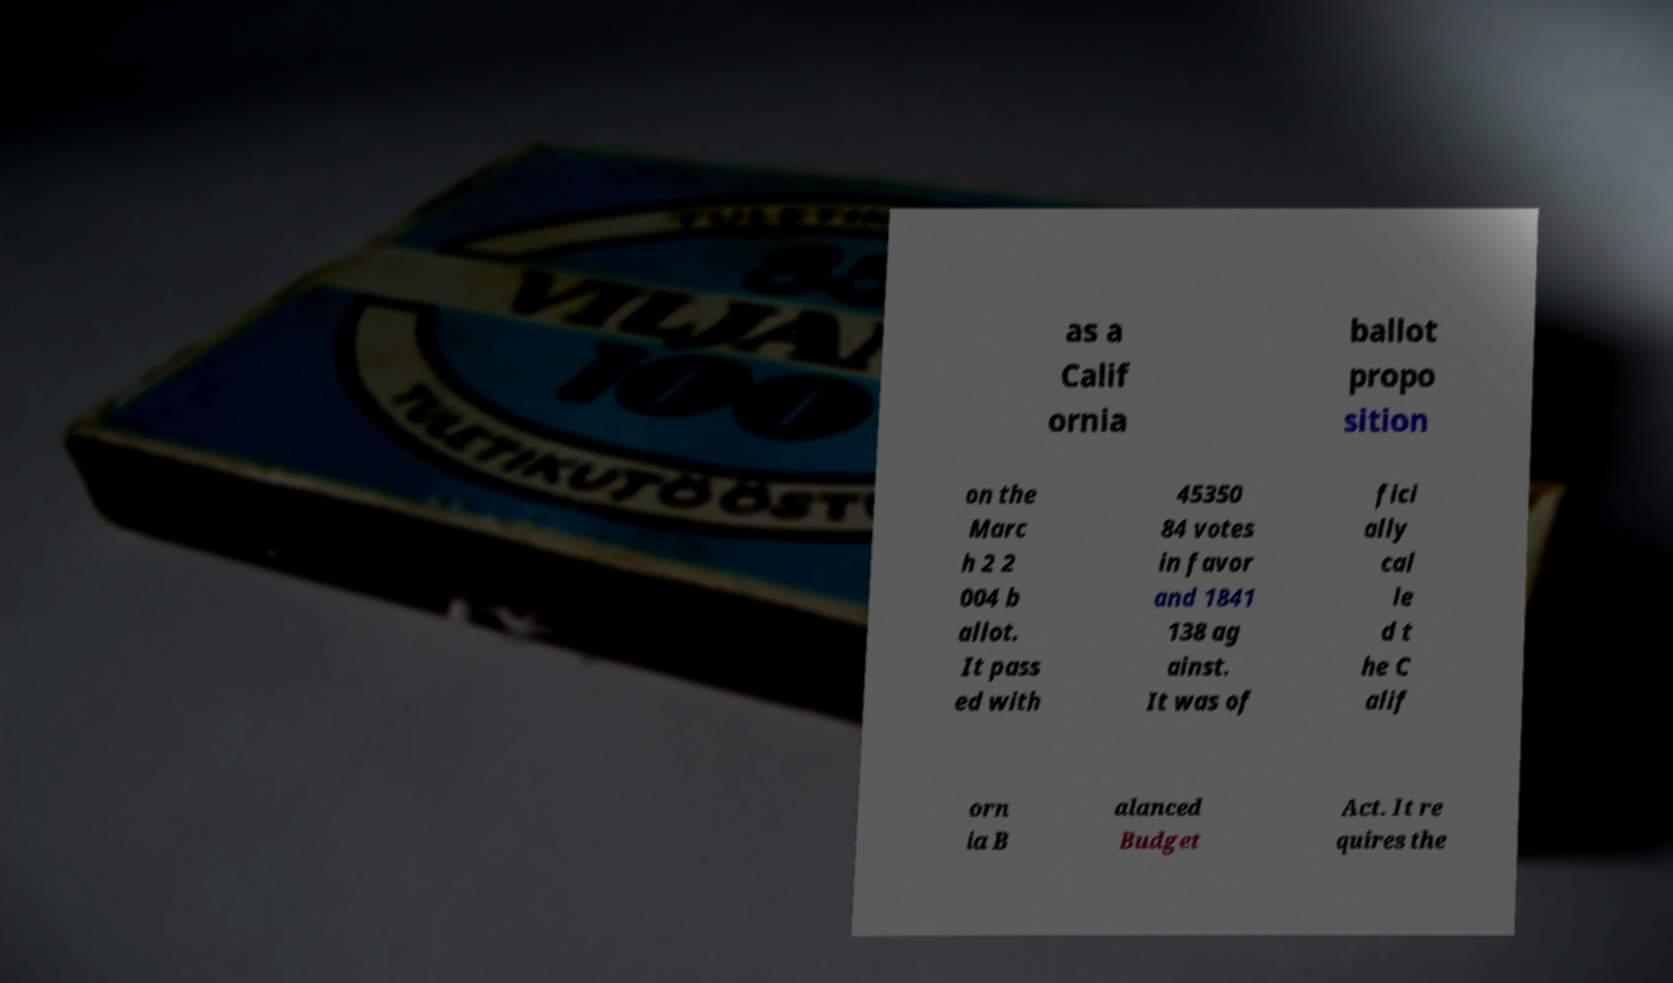Can you accurately transcribe the text from the provided image for me? as a Calif ornia ballot propo sition on the Marc h 2 2 004 b allot. It pass ed with 45350 84 votes in favor and 1841 138 ag ainst. It was of fici ally cal le d t he C alif orn ia B alanced Budget Act. It re quires the 